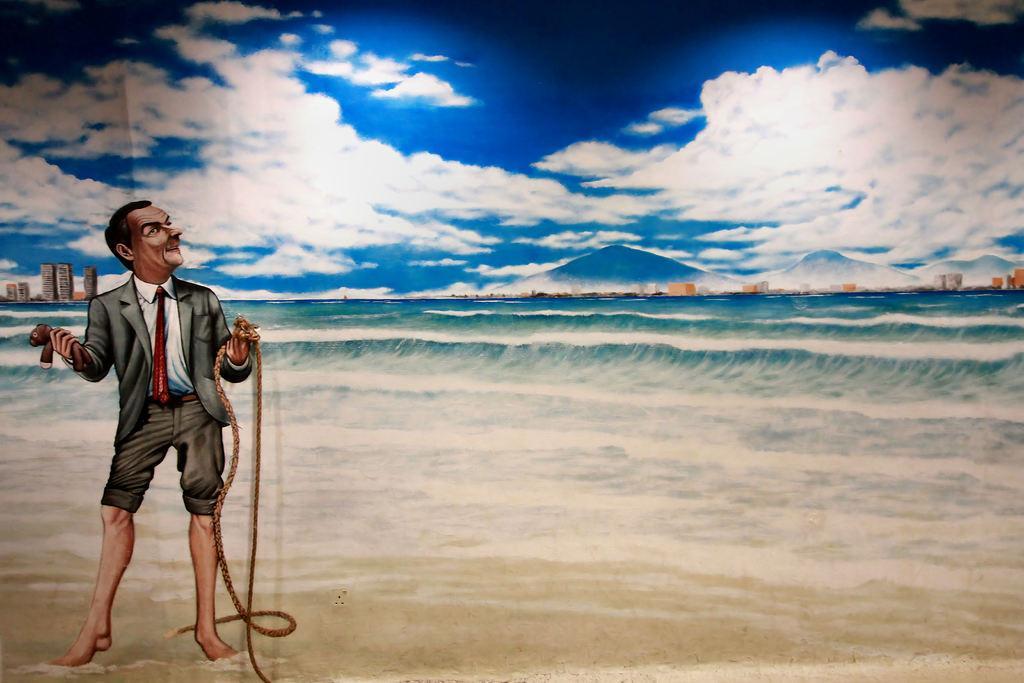Describe this image in one or two sentences. In this image, we can see depiction of a person on the beach. This person is holding a rope and doll with his hands. There are hills on the right side of the image. There are clouds in the sky. 